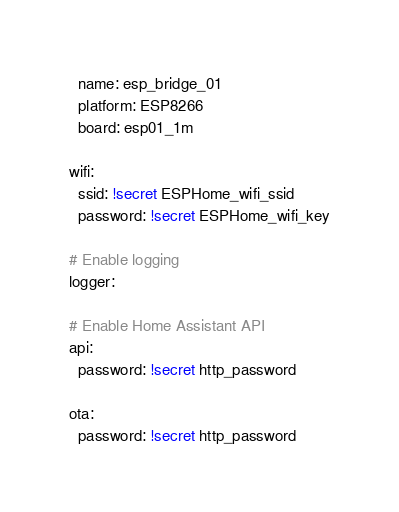<code> <loc_0><loc_0><loc_500><loc_500><_YAML_>  name: esp_bridge_01
  platform: ESP8266
  board: esp01_1m

wifi:
  ssid: !secret ESPHome_wifi_ssid
  password: !secret ESPHome_wifi_key

# Enable logging
logger:

# Enable Home Assistant API
api:
  password: !secret http_password

ota:
  password: !secret http_password</code> 